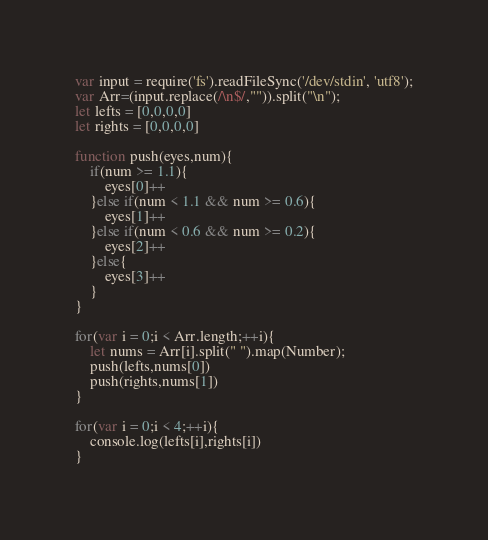<code> <loc_0><loc_0><loc_500><loc_500><_JavaScript_>var input = require('fs').readFileSync('/dev/stdin', 'utf8');
var Arr=(input.replace(/\n$/,"")).split("\n");
let lefts = [0,0,0,0]
let rights = [0,0,0,0]

function push(eyes,num){
    if(num >= 1.1){
        eyes[0]++
    }else if(num < 1.1 && num >= 0.6){
        eyes[1]++
    }else if(num < 0.6 && num >= 0.2){
        eyes[2]++
    }else{
        eyes[3]++
    }
}

for(var i = 0;i < Arr.length;++i){
    let nums = Arr[i].split(" ").map(Number);
    push(lefts,nums[0])
    push(rights,nums[1])
}

for(var i = 0;i < 4;++i){
    console.log(lefts[i],rights[i])
}
</code> 